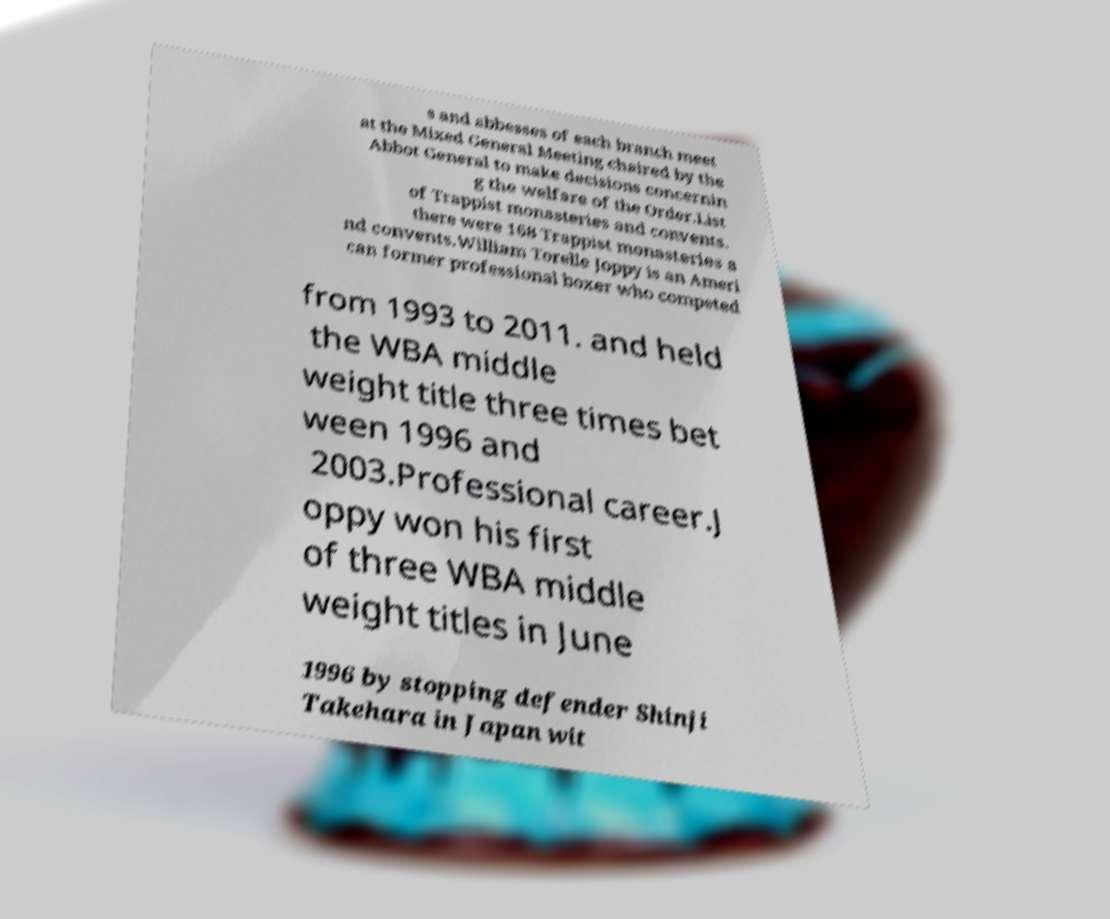There's text embedded in this image that I need extracted. Can you transcribe it verbatim? s and abbesses of each branch meet at the Mixed General Meeting chaired by the Abbot General to make decisions concernin g the welfare of the Order.List of Trappist monasteries and convents. there were 168 Trappist monasteries a nd convents.William Torelle Joppy is an Ameri can former professional boxer who competed from 1993 to 2011. and held the WBA middle weight title three times bet ween 1996 and 2003.Professional career.J oppy won his first of three WBA middle weight titles in June 1996 by stopping defender Shinji Takehara in Japan wit 